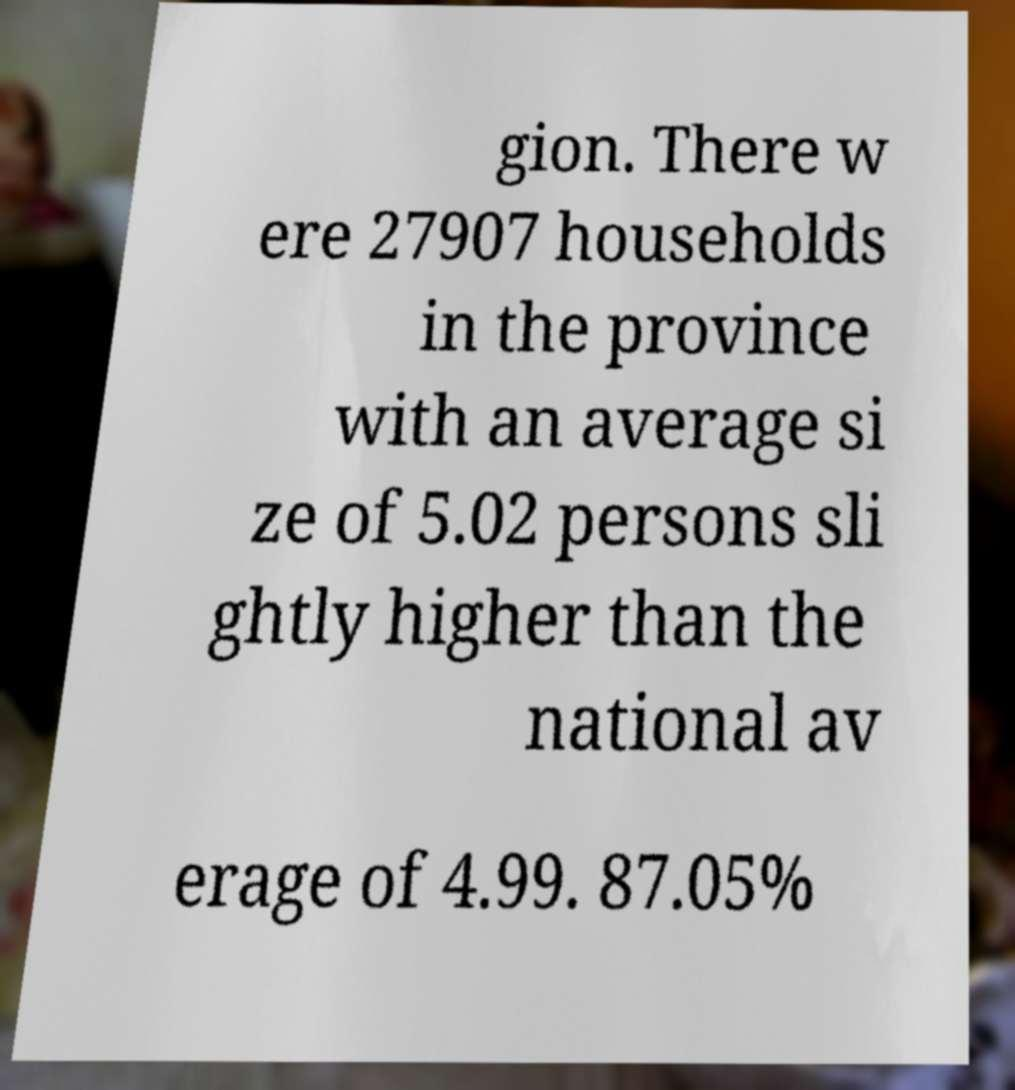Can you read and provide the text displayed in the image?This photo seems to have some interesting text. Can you extract and type it out for me? gion. There w ere 27907 households in the province with an average si ze of 5.02 persons sli ghtly higher than the national av erage of 4.99. 87.05% 